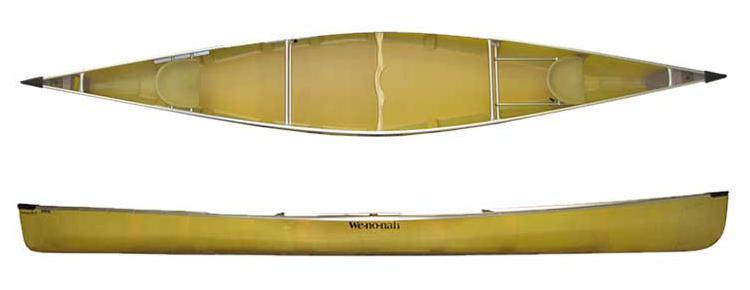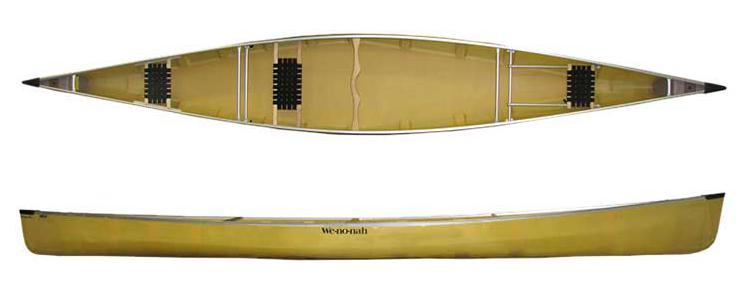The first image is the image on the left, the second image is the image on the right. Given the left and right images, does the statement "Both images show two views of a yellow-bodied canoe, and one features at least one woven black seat inside the canoe." hold true? Answer yes or no. Yes. 